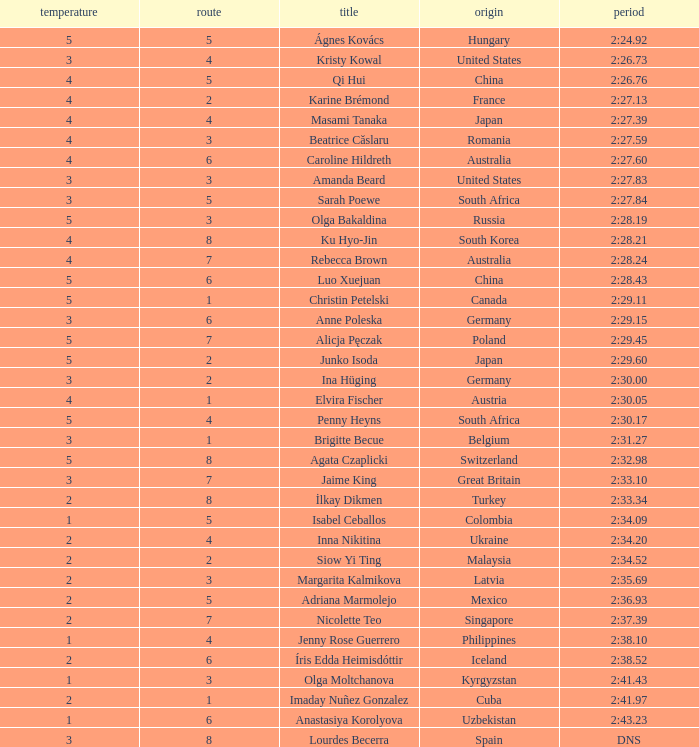What is the name that saw 4 heats and a lane higher than 7? Ku Hyo-Jin. 